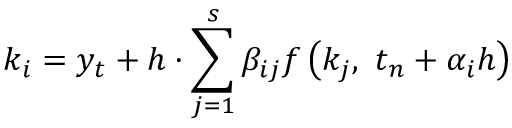Convert formula to latex. <formula><loc_0><loc_0><loc_500><loc_500>k _ { i } = y _ { t } + h \cdot \sum _ { j = 1 } ^ { s } \beta _ { i j } f \left ( k _ { j } , \ t _ { n } + \alpha _ { i } h \right )</formula> 